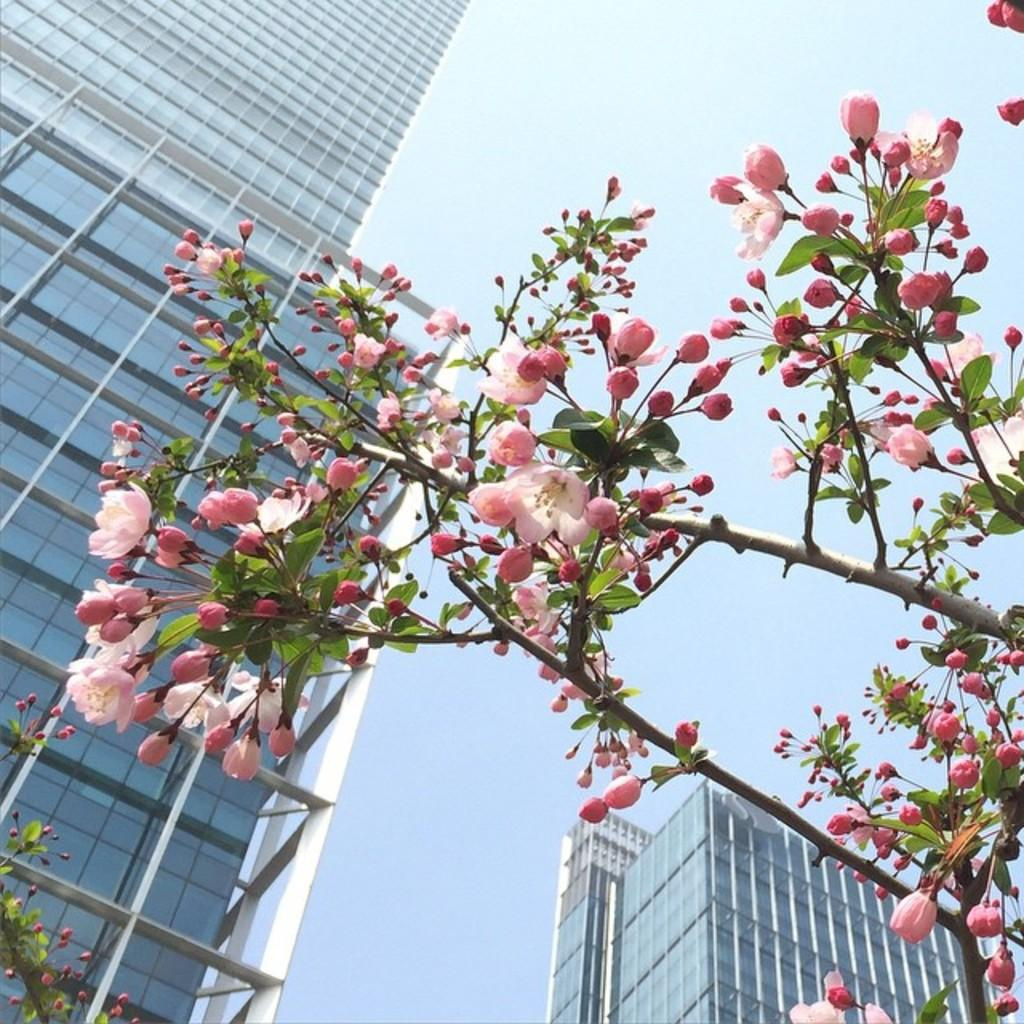What type of plant elements are present in the image? There are branches with flowers in the image. What else can be seen on the branches? There are leaves on the branches. What can be seen in the distance in the image? There are buildings in the background of the image. What is visible beyond the buildings? The sky is visible in the background of the image. What type of berry can be seen growing on the branches in the image? There are no berries present on the branches in the image; only flowers and leaves can be seen. 